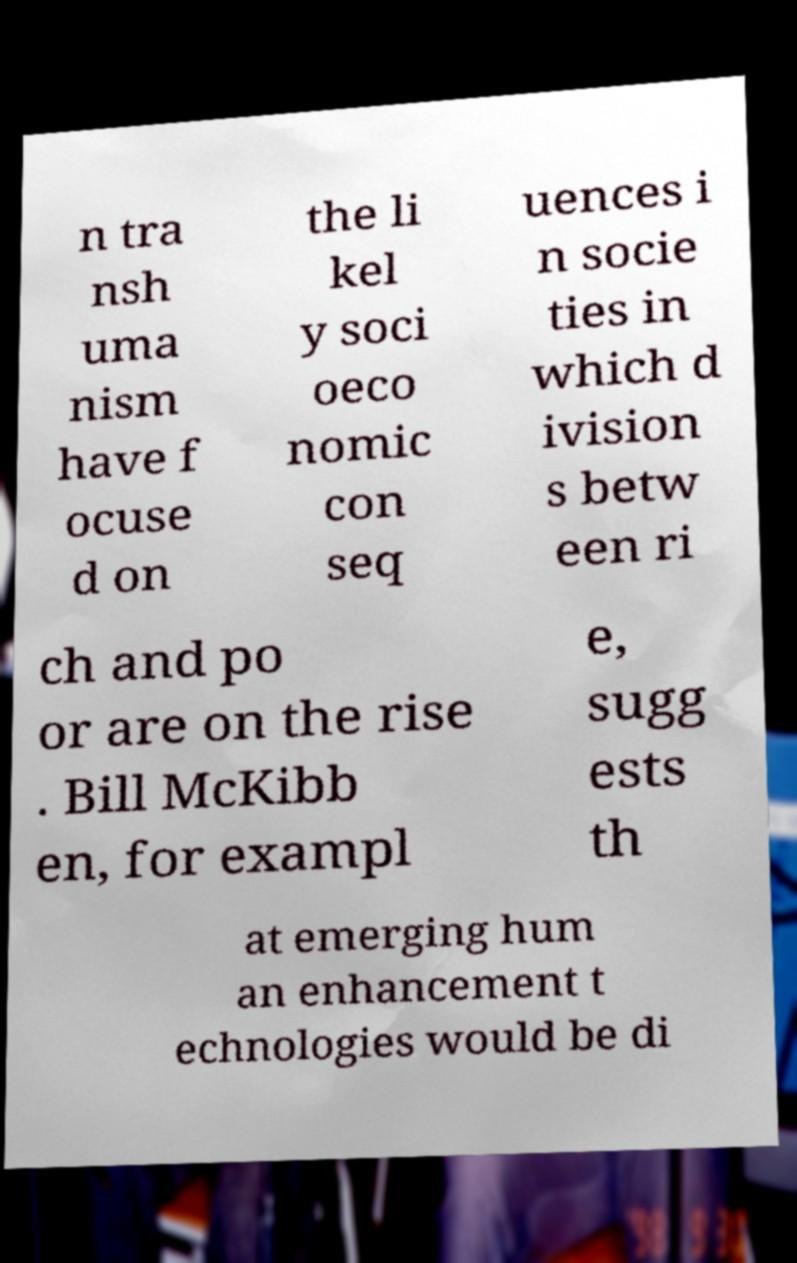Could you assist in decoding the text presented in this image and type it out clearly? n tra nsh uma nism have f ocuse d on the li kel y soci oeco nomic con seq uences i n socie ties in which d ivision s betw een ri ch and po or are on the rise . Bill McKibb en, for exampl e, sugg ests th at emerging hum an enhancement t echnologies would be di 